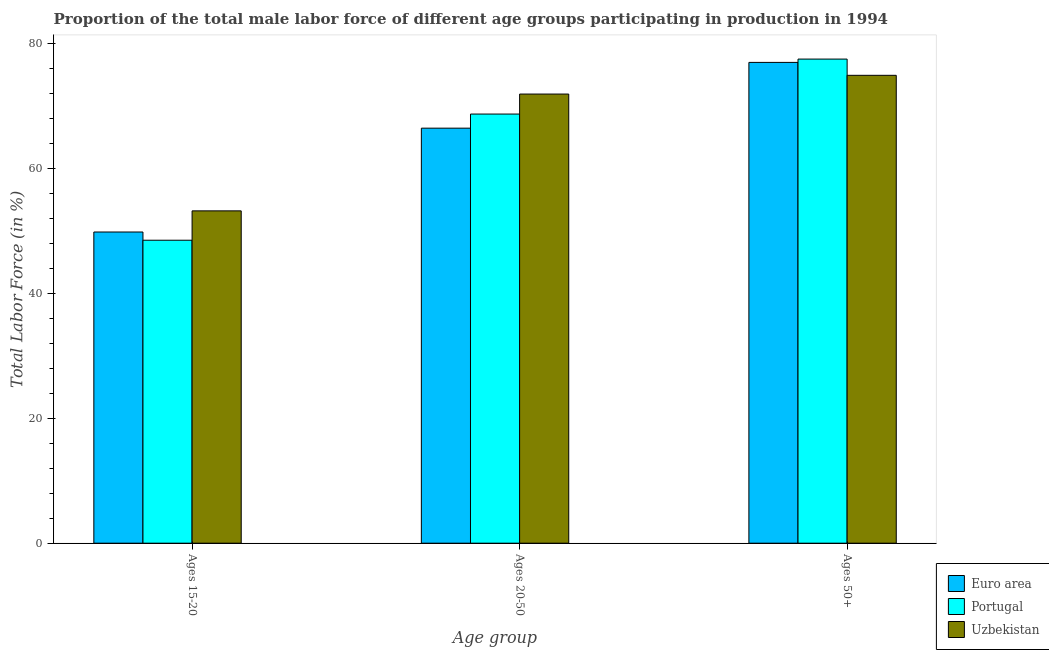How many different coloured bars are there?
Provide a succinct answer. 3. How many groups of bars are there?
Offer a terse response. 3. Are the number of bars on each tick of the X-axis equal?
Offer a terse response. Yes. What is the label of the 2nd group of bars from the left?
Offer a very short reply. Ages 20-50. What is the percentage of male labor force above age 50 in Uzbekistan?
Your answer should be very brief. 74.9. Across all countries, what is the maximum percentage of male labor force above age 50?
Your answer should be very brief. 77.5. Across all countries, what is the minimum percentage of male labor force above age 50?
Your answer should be very brief. 74.9. In which country was the percentage of male labor force within the age group 15-20 maximum?
Your answer should be compact. Uzbekistan. In which country was the percentage of male labor force within the age group 20-50 minimum?
Provide a succinct answer. Euro area. What is the total percentage of male labor force within the age group 15-20 in the graph?
Provide a succinct answer. 151.52. What is the difference between the percentage of male labor force within the age group 15-20 in Portugal and that in Euro area?
Offer a terse response. -1.32. What is the difference between the percentage of male labor force within the age group 20-50 in Uzbekistan and the percentage of male labor force within the age group 15-20 in Euro area?
Make the answer very short. 22.08. What is the average percentage of male labor force above age 50 per country?
Your response must be concise. 76.46. What is the difference between the percentage of male labor force above age 50 and percentage of male labor force within the age group 15-20 in Portugal?
Give a very brief answer. 29. In how many countries, is the percentage of male labor force within the age group 15-20 greater than 8 %?
Make the answer very short. 3. What is the ratio of the percentage of male labor force above age 50 in Uzbekistan to that in Euro area?
Provide a succinct answer. 0.97. Is the difference between the percentage of male labor force above age 50 in Portugal and Uzbekistan greater than the difference between the percentage of male labor force within the age group 20-50 in Portugal and Uzbekistan?
Offer a terse response. Yes. What is the difference between the highest and the second highest percentage of male labor force above age 50?
Keep it short and to the point. 0.53. What is the difference between the highest and the lowest percentage of male labor force within the age group 20-50?
Your response must be concise. 5.46. In how many countries, is the percentage of male labor force within the age group 20-50 greater than the average percentage of male labor force within the age group 20-50 taken over all countries?
Your response must be concise. 1. Is the sum of the percentage of male labor force within the age group 15-20 in Uzbekistan and Portugal greater than the maximum percentage of male labor force above age 50 across all countries?
Provide a succinct answer. Yes. What does the 2nd bar from the left in Ages 15-20 represents?
Provide a succinct answer. Portugal. What does the 1st bar from the right in Ages 15-20 represents?
Offer a very short reply. Uzbekistan. How many bars are there?
Keep it short and to the point. 9. Are all the bars in the graph horizontal?
Offer a terse response. No. Are the values on the major ticks of Y-axis written in scientific E-notation?
Offer a terse response. No. Does the graph contain grids?
Your response must be concise. No. Where does the legend appear in the graph?
Provide a succinct answer. Bottom right. What is the title of the graph?
Ensure brevity in your answer.  Proportion of the total male labor force of different age groups participating in production in 1994. Does "Canada" appear as one of the legend labels in the graph?
Ensure brevity in your answer.  No. What is the label or title of the X-axis?
Make the answer very short. Age group. What is the Total Labor Force (in %) of Euro area in Ages 15-20?
Your answer should be compact. 49.82. What is the Total Labor Force (in %) in Portugal in Ages 15-20?
Offer a very short reply. 48.5. What is the Total Labor Force (in %) of Uzbekistan in Ages 15-20?
Provide a succinct answer. 53.2. What is the Total Labor Force (in %) in Euro area in Ages 20-50?
Give a very brief answer. 66.44. What is the Total Labor Force (in %) of Portugal in Ages 20-50?
Make the answer very short. 68.7. What is the Total Labor Force (in %) in Uzbekistan in Ages 20-50?
Offer a terse response. 71.9. What is the Total Labor Force (in %) of Euro area in Ages 50+?
Your answer should be very brief. 76.97. What is the Total Labor Force (in %) of Portugal in Ages 50+?
Your response must be concise. 77.5. What is the Total Labor Force (in %) in Uzbekistan in Ages 50+?
Your answer should be compact. 74.9. Across all Age group, what is the maximum Total Labor Force (in %) in Euro area?
Provide a short and direct response. 76.97. Across all Age group, what is the maximum Total Labor Force (in %) in Portugal?
Your response must be concise. 77.5. Across all Age group, what is the maximum Total Labor Force (in %) in Uzbekistan?
Your answer should be compact. 74.9. Across all Age group, what is the minimum Total Labor Force (in %) in Euro area?
Offer a terse response. 49.82. Across all Age group, what is the minimum Total Labor Force (in %) of Portugal?
Make the answer very short. 48.5. Across all Age group, what is the minimum Total Labor Force (in %) of Uzbekistan?
Offer a very short reply. 53.2. What is the total Total Labor Force (in %) of Euro area in the graph?
Your response must be concise. 193.22. What is the total Total Labor Force (in %) in Portugal in the graph?
Your answer should be compact. 194.7. What is the difference between the Total Labor Force (in %) of Euro area in Ages 15-20 and that in Ages 20-50?
Your response must be concise. -16.62. What is the difference between the Total Labor Force (in %) in Portugal in Ages 15-20 and that in Ages 20-50?
Your response must be concise. -20.2. What is the difference between the Total Labor Force (in %) in Uzbekistan in Ages 15-20 and that in Ages 20-50?
Your response must be concise. -18.7. What is the difference between the Total Labor Force (in %) in Euro area in Ages 15-20 and that in Ages 50+?
Your response must be concise. -27.15. What is the difference between the Total Labor Force (in %) in Portugal in Ages 15-20 and that in Ages 50+?
Give a very brief answer. -29. What is the difference between the Total Labor Force (in %) of Uzbekistan in Ages 15-20 and that in Ages 50+?
Provide a succinct answer. -21.7. What is the difference between the Total Labor Force (in %) of Euro area in Ages 20-50 and that in Ages 50+?
Make the answer very short. -10.53. What is the difference between the Total Labor Force (in %) in Euro area in Ages 15-20 and the Total Labor Force (in %) in Portugal in Ages 20-50?
Offer a terse response. -18.88. What is the difference between the Total Labor Force (in %) of Euro area in Ages 15-20 and the Total Labor Force (in %) of Uzbekistan in Ages 20-50?
Give a very brief answer. -22.08. What is the difference between the Total Labor Force (in %) in Portugal in Ages 15-20 and the Total Labor Force (in %) in Uzbekistan in Ages 20-50?
Your answer should be compact. -23.4. What is the difference between the Total Labor Force (in %) of Euro area in Ages 15-20 and the Total Labor Force (in %) of Portugal in Ages 50+?
Your response must be concise. -27.68. What is the difference between the Total Labor Force (in %) in Euro area in Ages 15-20 and the Total Labor Force (in %) in Uzbekistan in Ages 50+?
Keep it short and to the point. -25.08. What is the difference between the Total Labor Force (in %) in Portugal in Ages 15-20 and the Total Labor Force (in %) in Uzbekistan in Ages 50+?
Offer a very short reply. -26.4. What is the difference between the Total Labor Force (in %) of Euro area in Ages 20-50 and the Total Labor Force (in %) of Portugal in Ages 50+?
Your response must be concise. -11.06. What is the difference between the Total Labor Force (in %) in Euro area in Ages 20-50 and the Total Labor Force (in %) in Uzbekistan in Ages 50+?
Provide a succinct answer. -8.46. What is the difference between the Total Labor Force (in %) in Portugal in Ages 20-50 and the Total Labor Force (in %) in Uzbekistan in Ages 50+?
Provide a succinct answer. -6.2. What is the average Total Labor Force (in %) of Euro area per Age group?
Provide a succinct answer. 64.41. What is the average Total Labor Force (in %) in Portugal per Age group?
Offer a very short reply. 64.9. What is the average Total Labor Force (in %) in Uzbekistan per Age group?
Offer a very short reply. 66.67. What is the difference between the Total Labor Force (in %) in Euro area and Total Labor Force (in %) in Portugal in Ages 15-20?
Keep it short and to the point. 1.32. What is the difference between the Total Labor Force (in %) in Euro area and Total Labor Force (in %) in Uzbekistan in Ages 15-20?
Ensure brevity in your answer.  -3.38. What is the difference between the Total Labor Force (in %) of Portugal and Total Labor Force (in %) of Uzbekistan in Ages 15-20?
Offer a very short reply. -4.7. What is the difference between the Total Labor Force (in %) of Euro area and Total Labor Force (in %) of Portugal in Ages 20-50?
Your answer should be very brief. -2.26. What is the difference between the Total Labor Force (in %) in Euro area and Total Labor Force (in %) in Uzbekistan in Ages 20-50?
Provide a short and direct response. -5.46. What is the difference between the Total Labor Force (in %) in Euro area and Total Labor Force (in %) in Portugal in Ages 50+?
Give a very brief answer. -0.53. What is the difference between the Total Labor Force (in %) of Euro area and Total Labor Force (in %) of Uzbekistan in Ages 50+?
Give a very brief answer. 2.07. What is the difference between the Total Labor Force (in %) of Portugal and Total Labor Force (in %) of Uzbekistan in Ages 50+?
Your answer should be compact. 2.6. What is the ratio of the Total Labor Force (in %) of Euro area in Ages 15-20 to that in Ages 20-50?
Give a very brief answer. 0.75. What is the ratio of the Total Labor Force (in %) in Portugal in Ages 15-20 to that in Ages 20-50?
Give a very brief answer. 0.71. What is the ratio of the Total Labor Force (in %) in Uzbekistan in Ages 15-20 to that in Ages 20-50?
Your response must be concise. 0.74. What is the ratio of the Total Labor Force (in %) of Euro area in Ages 15-20 to that in Ages 50+?
Offer a very short reply. 0.65. What is the ratio of the Total Labor Force (in %) in Portugal in Ages 15-20 to that in Ages 50+?
Your answer should be very brief. 0.63. What is the ratio of the Total Labor Force (in %) in Uzbekistan in Ages 15-20 to that in Ages 50+?
Keep it short and to the point. 0.71. What is the ratio of the Total Labor Force (in %) in Euro area in Ages 20-50 to that in Ages 50+?
Keep it short and to the point. 0.86. What is the ratio of the Total Labor Force (in %) in Portugal in Ages 20-50 to that in Ages 50+?
Offer a terse response. 0.89. What is the ratio of the Total Labor Force (in %) of Uzbekistan in Ages 20-50 to that in Ages 50+?
Give a very brief answer. 0.96. What is the difference between the highest and the second highest Total Labor Force (in %) in Euro area?
Your answer should be compact. 10.53. What is the difference between the highest and the second highest Total Labor Force (in %) of Portugal?
Ensure brevity in your answer.  8.8. What is the difference between the highest and the lowest Total Labor Force (in %) of Euro area?
Your answer should be very brief. 27.15. What is the difference between the highest and the lowest Total Labor Force (in %) of Uzbekistan?
Offer a very short reply. 21.7. 